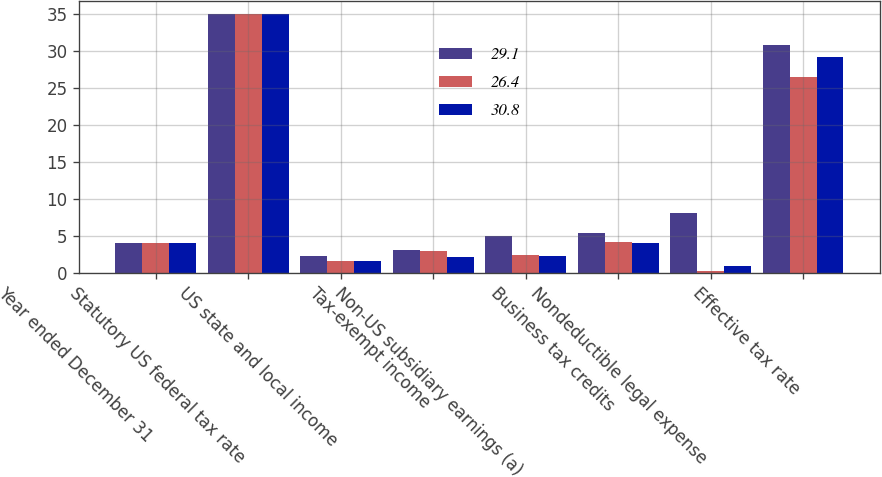<chart> <loc_0><loc_0><loc_500><loc_500><stacked_bar_chart><ecel><fcel>Year ended December 31<fcel>Statutory US federal tax rate<fcel>US state and local income<fcel>Tax-exempt income<fcel>Non-US subsidiary earnings (a)<fcel>Business tax credits<fcel>Nondeductible legal expense<fcel>Effective tax rate<nl><fcel>29.1<fcel>4<fcel>35<fcel>2.2<fcel>3.1<fcel>4.9<fcel>5.4<fcel>8<fcel>30.8<nl><fcel>26.4<fcel>4<fcel>35<fcel>1.6<fcel>2.9<fcel>2.4<fcel>4.2<fcel>0.2<fcel>26.4<nl><fcel>30.8<fcel>4<fcel>35<fcel>1.6<fcel>2.1<fcel>2.3<fcel>4<fcel>0.9<fcel>29.1<nl></chart> 